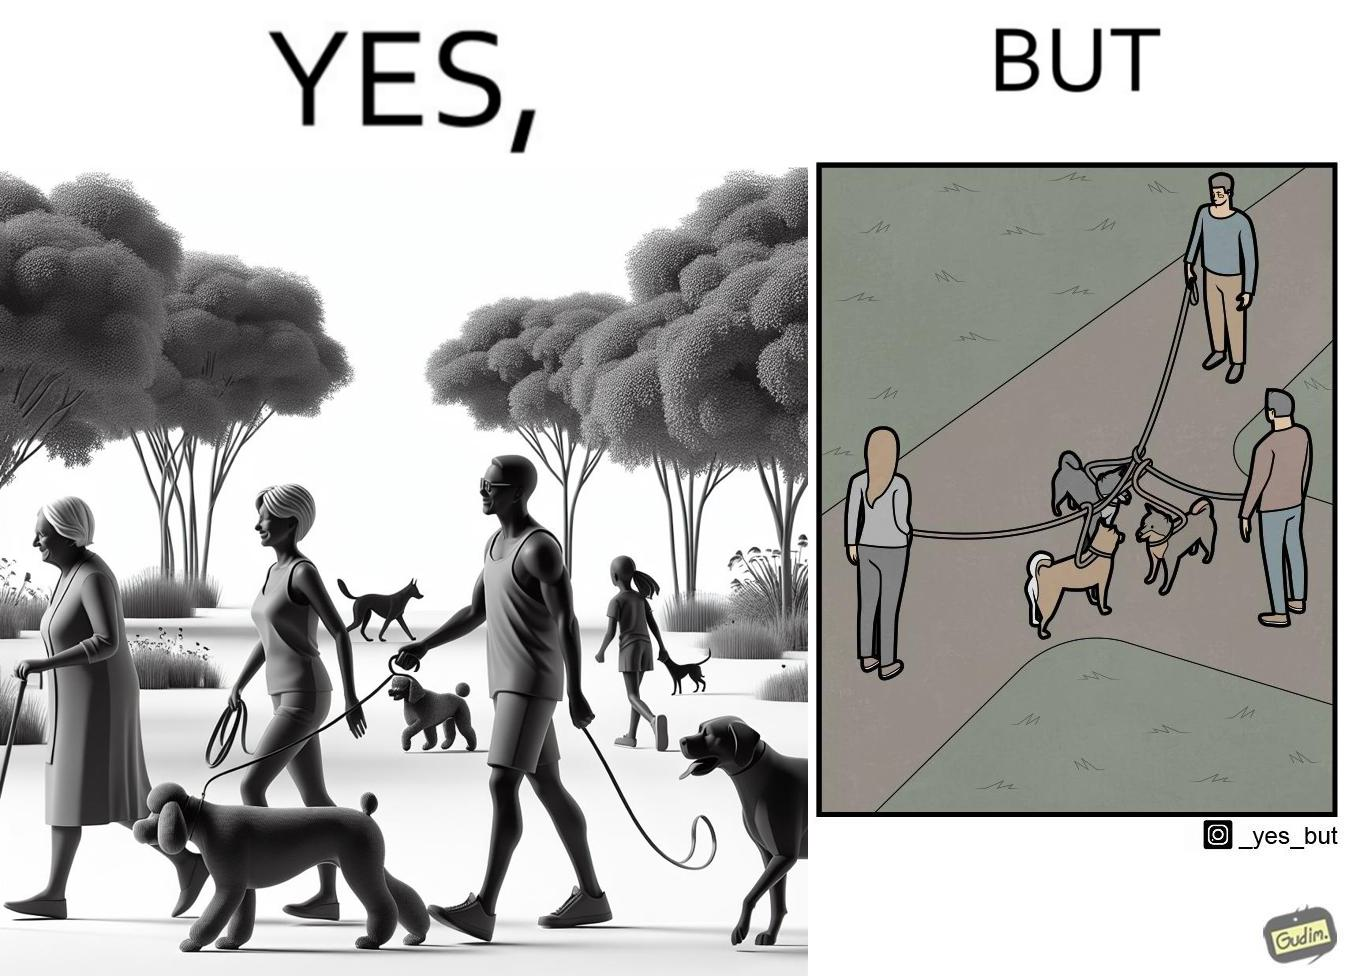Why is this image considered satirical? The dog owners take their dogs for some walk in parks but their dogs mingle together with other dogs however their leashes get entangled during this which is quite inconvenient for the dog owners 